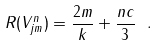Convert formula to latex. <formula><loc_0><loc_0><loc_500><loc_500>R ( V _ { j m } ^ { n } ) = \frac { 2 m } { k } + \frac { n c } { 3 } \ .</formula> 